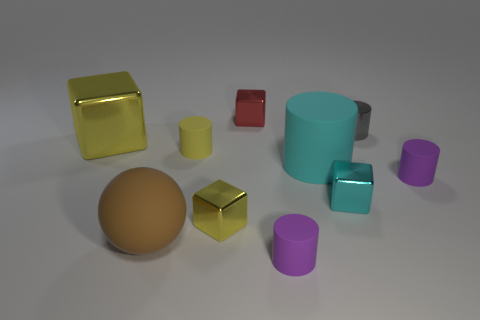Subtract all yellow blocks. How many were subtracted if there are1yellow blocks left? 1 Subtract 1 cylinders. How many cylinders are left? 4 Subtract all yellow cylinders. How many cylinders are left? 4 Subtract all metallic cylinders. How many cylinders are left? 4 Subtract all red cylinders. Subtract all cyan spheres. How many cylinders are left? 5 Subtract all spheres. How many objects are left? 9 Subtract 1 yellow cubes. How many objects are left? 9 Subtract all large yellow blocks. Subtract all gray metal things. How many objects are left? 8 Add 5 small gray cylinders. How many small gray cylinders are left? 6 Add 4 big cyan rubber objects. How many big cyan rubber objects exist? 5 